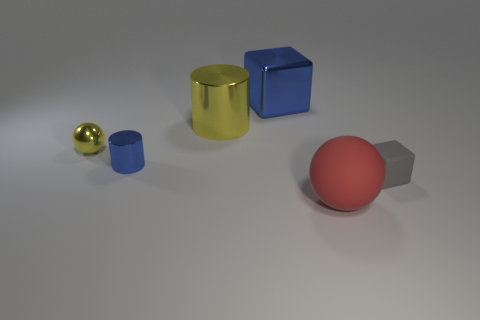What can you infer about the texture of the objects? From the image, it can be inferred that the yellow cylinder and the small golden sphere have a smooth metallic texture. The blue cube and small blue cylinder seem to have a slightly reflective, possibly plastic texture, while the red sphere has a matte and rougher surface. 